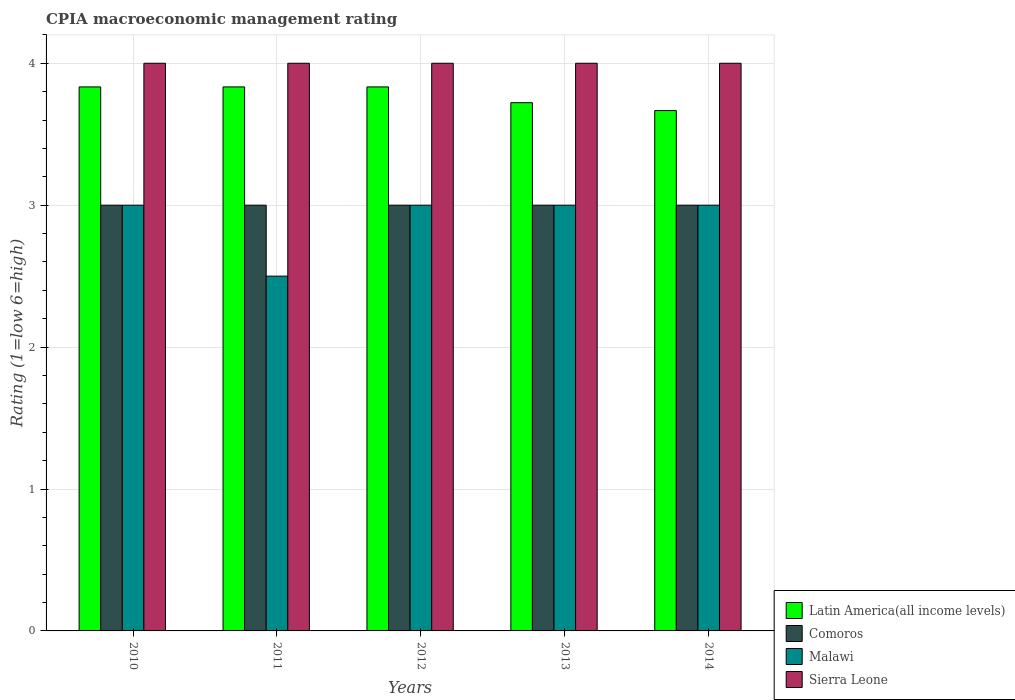How many different coloured bars are there?
Offer a very short reply. 4. How many groups of bars are there?
Provide a succinct answer. 5. Are the number of bars per tick equal to the number of legend labels?
Give a very brief answer. Yes. How many bars are there on the 5th tick from the right?
Ensure brevity in your answer.  4. In how many cases, is the number of bars for a given year not equal to the number of legend labels?
Your answer should be compact. 0. What is the CPIA rating in Sierra Leone in 2010?
Your response must be concise. 4. Across all years, what is the maximum CPIA rating in Sierra Leone?
Your answer should be very brief. 4. Across all years, what is the minimum CPIA rating in Sierra Leone?
Offer a very short reply. 4. In which year was the CPIA rating in Sierra Leone maximum?
Your answer should be very brief. 2010. In which year was the CPIA rating in Comoros minimum?
Your response must be concise. 2010. What is the total CPIA rating in Comoros in the graph?
Provide a short and direct response. 15. What is the difference between the CPIA rating in Latin America(all income levels) in 2013 and that in 2014?
Provide a succinct answer. 0.06. In the year 2014, what is the difference between the CPIA rating in Latin America(all income levels) and CPIA rating in Sierra Leone?
Provide a short and direct response. -0.33. What is the ratio of the CPIA rating in Sierra Leone in 2010 to that in 2014?
Make the answer very short. 1. Is the difference between the CPIA rating in Latin America(all income levels) in 2010 and 2011 greater than the difference between the CPIA rating in Sierra Leone in 2010 and 2011?
Keep it short and to the point. No. What is the difference between the highest and the second highest CPIA rating in Malawi?
Ensure brevity in your answer.  0. What does the 2nd bar from the left in 2010 represents?
Your answer should be very brief. Comoros. What does the 4th bar from the right in 2014 represents?
Offer a terse response. Latin America(all income levels). How many bars are there?
Your response must be concise. 20. Does the graph contain any zero values?
Ensure brevity in your answer.  No. Does the graph contain grids?
Ensure brevity in your answer.  Yes. How are the legend labels stacked?
Your response must be concise. Vertical. What is the title of the graph?
Offer a terse response. CPIA macroeconomic management rating. What is the label or title of the X-axis?
Your answer should be very brief. Years. What is the Rating (1=low 6=high) in Latin America(all income levels) in 2010?
Provide a succinct answer. 3.83. What is the Rating (1=low 6=high) of Malawi in 2010?
Offer a terse response. 3. What is the Rating (1=low 6=high) in Latin America(all income levels) in 2011?
Your answer should be very brief. 3.83. What is the Rating (1=low 6=high) of Sierra Leone in 2011?
Your answer should be very brief. 4. What is the Rating (1=low 6=high) of Latin America(all income levels) in 2012?
Provide a short and direct response. 3.83. What is the Rating (1=low 6=high) of Malawi in 2012?
Provide a succinct answer. 3. What is the Rating (1=low 6=high) in Sierra Leone in 2012?
Ensure brevity in your answer.  4. What is the Rating (1=low 6=high) of Latin America(all income levels) in 2013?
Your response must be concise. 3.72. What is the Rating (1=low 6=high) in Comoros in 2013?
Keep it short and to the point. 3. What is the Rating (1=low 6=high) in Sierra Leone in 2013?
Your response must be concise. 4. What is the Rating (1=low 6=high) of Latin America(all income levels) in 2014?
Your answer should be very brief. 3.67. What is the Rating (1=low 6=high) in Malawi in 2014?
Make the answer very short. 3. What is the Rating (1=low 6=high) in Sierra Leone in 2014?
Make the answer very short. 4. Across all years, what is the maximum Rating (1=low 6=high) in Latin America(all income levels)?
Offer a terse response. 3.83. Across all years, what is the maximum Rating (1=low 6=high) in Comoros?
Provide a succinct answer. 3. Across all years, what is the maximum Rating (1=low 6=high) in Malawi?
Provide a short and direct response. 3. Across all years, what is the minimum Rating (1=low 6=high) in Latin America(all income levels)?
Your answer should be very brief. 3.67. Across all years, what is the minimum Rating (1=low 6=high) in Comoros?
Your answer should be very brief. 3. Across all years, what is the minimum Rating (1=low 6=high) in Malawi?
Offer a terse response. 2.5. Across all years, what is the minimum Rating (1=low 6=high) of Sierra Leone?
Offer a terse response. 4. What is the total Rating (1=low 6=high) of Latin America(all income levels) in the graph?
Your response must be concise. 18.89. What is the total Rating (1=low 6=high) in Comoros in the graph?
Offer a terse response. 15. What is the total Rating (1=low 6=high) of Malawi in the graph?
Make the answer very short. 14.5. What is the difference between the Rating (1=low 6=high) of Latin America(all income levels) in 2010 and that in 2011?
Offer a very short reply. 0. What is the difference between the Rating (1=low 6=high) of Sierra Leone in 2010 and that in 2011?
Provide a succinct answer. 0. What is the difference between the Rating (1=low 6=high) of Latin America(all income levels) in 2010 and that in 2012?
Ensure brevity in your answer.  0. What is the difference between the Rating (1=low 6=high) in Comoros in 2010 and that in 2012?
Offer a very short reply. 0. What is the difference between the Rating (1=low 6=high) of Malawi in 2010 and that in 2012?
Provide a short and direct response. 0. What is the difference between the Rating (1=low 6=high) in Sierra Leone in 2010 and that in 2012?
Your response must be concise. 0. What is the difference between the Rating (1=low 6=high) of Latin America(all income levels) in 2010 and that in 2013?
Keep it short and to the point. 0.11. What is the difference between the Rating (1=low 6=high) of Comoros in 2010 and that in 2013?
Make the answer very short. 0. What is the difference between the Rating (1=low 6=high) in Sierra Leone in 2010 and that in 2013?
Make the answer very short. 0. What is the difference between the Rating (1=low 6=high) in Latin America(all income levels) in 2010 and that in 2014?
Give a very brief answer. 0.17. What is the difference between the Rating (1=low 6=high) in Comoros in 2010 and that in 2014?
Your answer should be very brief. 0. What is the difference between the Rating (1=low 6=high) of Comoros in 2011 and that in 2012?
Your answer should be very brief. 0. What is the difference between the Rating (1=low 6=high) of Malawi in 2011 and that in 2012?
Provide a succinct answer. -0.5. What is the difference between the Rating (1=low 6=high) in Comoros in 2011 and that in 2013?
Give a very brief answer. 0. What is the difference between the Rating (1=low 6=high) in Malawi in 2011 and that in 2013?
Your answer should be very brief. -0.5. What is the difference between the Rating (1=low 6=high) of Latin America(all income levels) in 2011 and that in 2014?
Provide a short and direct response. 0.17. What is the difference between the Rating (1=low 6=high) of Malawi in 2011 and that in 2014?
Offer a terse response. -0.5. What is the difference between the Rating (1=low 6=high) of Latin America(all income levels) in 2012 and that in 2013?
Provide a short and direct response. 0.11. What is the difference between the Rating (1=low 6=high) of Comoros in 2012 and that in 2013?
Offer a terse response. 0. What is the difference between the Rating (1=low 6=high) of Sierra Leone in 2012 and that in 2013?
Give a very brief answer. 0. What is the difference between the Rating (1=low 6=high) in Latin America(all income levels) in 2012 and that in 2014?
Make the answer very short. 0.17. What is the difference between the Rating (1=low 6=high) of Comoros in 2012 and that in 2014?
Offer a terse response. 0. What is the difference between the Rating (1=low 6=high) in Sierra Leone in 2012 and that in 2014?
Ensure brevity in your answer.  0. What is the difference between the Rating (1=low 6=high) of Latin America(all income levels) in 2013 and that in 2014?
Provide a short and direct response. 0.06. What is the difference between the Rating (1=low 6=high) of Comoros in 2013 and that in 2014?
Ensure brevity in your answer.  0. What is the difference between the Rating (1=low 6=high) in Malawi in 2013 and that in 2014?
Your response must be concise. 0. What is the difference between the Rating (1=low 6=high) of Latin America(all income levels) in 2010 and the Rating (1=low 6=high) of Comoros in 2011?
Your response must be concise. 0.83. What is the difference between the Rating (1=low 6=high) in Comoros in 2010 and the Rating (1=low 6=high) in Malawi in 2011?
Give a very brief answer. 0.5. What is the difference between the Rating (1=low 6=high) in Latin America(all income levels) in 2010 and the Rating (1=low 6=high) in Comoros in 2012?
Your answer should be compact. 0.83. What is the difference between the Rating (1=low 6=high) of Latin America(all income levels) in 2010 and the Rating (1=low 6=high) of Sierra Leone in 2012?
Provide a succinct answer. -0.17. What is the difference between the Rating (1=low 6=high) of Comoros in 2010 and the Rating (1=low 6=high) of Malawi in 2012?
Make the answer very short. 0. What is the difference between the Rating (1=low 6=high) of Comoros in 2010 and the Rating (1=low 6=high) of Sierra Leone in 2012?
Ensure brevity in your answer.  -1. What is the difference between the Rating (1=low 6=high) in Malawi in 2010 and the Rating (1=low 6=high) in Sierra Leone in 2012?
Keep it short and to the point. -1. What is the difference between the Rating (1=low 6=high) of Latin America(all income levels) in 2010 and the Rating (1=low 6=high) of Comoros in 2013?
Your response must be concise. 0.83. What is the difference between the Rating (1=low 6=high) of Latin America(all income levels) in 2010 and the Rating (1=low 6=high) of Sierra Leone in 2013?
Keep it short and to the point. -0.17. What is the difference between the Rating (1=low 6=high) in Comoros in 2010 and the Rating (1=low 6=high) in Malawi in 2013?
Your answer should be compact. 0. What is the difference between the Rating (1=low 6=high) in Comoros in 2010 and the Rating (1=low 6=high) in Sierra Leone in 2013?
Provide a succinct answer. -1. What is the difference between the Rating (1=low 6=high) of Latin America(all income levels) in 2010 and the Rating (1=low 6=high) of Comoros in 2014?
Provide a succinct answer. 0.83. What is the difference between the Rating (1=low 6=high) of Latin America(all income levels) in 2010 and the Rating (1=low 6=high) of Malawi in 2014?
Ensure brevity in your answer.  0.83. What is the difference between the Rating (1=low 6=high) in Comoros in 2010 and the Rating (1=low 6=high) in Sierra Leone in 2014?
Your answer should be very brief. -1. What is the difference between the Rating (1=low 6=high) in Latin America(all income levels) in 2011 and the Rating (1=low 6=high) in Malawi in 2012?
Keep it short and to the point. 0.83. What is the difference between the Rating (1=low 6=high) of Comoros in 2011 and the Rating (1=low 6=high) of Malawi in 2012?
Offer a very short reply. 0. What is the difference between the Rating (1=low 6=high) in Latin America(all income levels) in 2011 and the Rating (1=low 6=high) in Comoros in 2013?
Your response must be concise. 0.83. What is the difference between the Rating (1=low 6=high) of Latin America(all income levels) in 2011 and the Rating (1=low 6=high) of Malawi in 2013?
Ensure brevity in your answer.  0.83. What is the difference between the Rating (1=low 6=high) in Latin America(all income levels) in 2011 and the Rating (1=low 6=high) in Sierra Leone in 2013?
Keep it short and to the point. -0.17. What is the difference between the Rating (1=low 6=high) of Comoros in 2011 and the Rating (1=low 6=high) of Malawi in 2013?
Keep it short and to the point. 0. What is the difference between the Rating (1=low 6=high) of Latin America(all income levels) in 2011 and the Rating (1=low 6=high) of Comoros in 2014?
Give a very brief answer. 0.83. What is the difference between the Rating (1=low 6=high) of Comoros in 2011 and the Rating (1=low 6=high) of Malawi in 2014?
Make the answer very short. 0. What is the difference between the Rating (1=low 6=high) of Comoros in 2011 and the Rating (1=low 6=high) of Sierra Leone in 2014?
Your response must be concise. -1. What is the difference between the Rating (1=low 6=high) of Latin America(all income levels) in 2012 and the Rating (1=low 6=high) of Comoros in 2013?
Provide a succinct answer. 0.83. What is the difference between the Rating (1=low 6=high) of Comoros in 2012 and the Rating (1=low 6=high) of Sierra Leone in 2013?
Give a very brief answer. -1. What is the difference between the Rating (1=low 6=high) of Malawi in 2012 and the Rating (1=low 6=high) of Sierra Leone in 2013?
Your response must be concise. -1. What is the difference between the Rating (1=low 6=high) of Latin America(all income levels) in 2012 and the Rating (1=low 6=high) of Comoros in 2014?
Your response must be concise. 0.83. What is the difference between the Rating (1=low 6=high) in Latin America(all income levels) in 2012 and the Rating (1=low 6=high) in Sierra Leone in 2014?
Your response must be concise. -0.17. What is the difference between the Rating (1=low 6=high) in Comoros in 2012 and the Rating (1=low 6=high) in Sierra Leone in 2014?
Give a very brief answer. -1. What is the difference between the Rating (1=low 6=high) in Latin America(all income levels) in 2013 and the Rating (1=low 6=high) in Comoros in 2014?
Provide a succinct answer. 0.72. What is the difference between the Rating (1=low 6=high) in Latin America(all income levels) in 2013 and the Rating (1=low 6=high) in Malawi in 2014?
Offer a terse response. 0.72. What is the difference between the Rating (1=low 6=high) of Latin America(all income levels) in 2013 and the Rating (1=low 6=high) of Sierra Leone in 2014?
Make the answer very short. -0.28. What is the difference between the Rating (1=low 6=high) of Comoros in 2013 and the Rating (1=low 6=high) of Malawi in 2014?
Offer a very short reply. 0. What is the average Rating (1=low 6=high) in Latin America(all income levels) per year?
Your answer should be very brief. 3.78. In the year 2010, what is the difference between the Rating (1=low 6=high) in Latin America(all income levels) and Rating (1=low 6=high) in Malawi?
Provide a short and direct response. 0.83. In the year 2010, what is the difference between the Rating (1=low 6=high) in Latin America(all income levels) and Rating (1=low 6=high) in Sierra Leone?
Offer a very short reply. -0.17. In the year 2010, what is the difference between the Rating (1=low 6=high) of Comoros and Rating (1=low 6=high) of Sierra Leone?
Make the answer very short. -1. In the year 2011, what is the difference between the Rating (1=low 6=high) in Latin America(all income levels) and Rating (1=low 6=high) in Comoros?
Ensure brevity in your answer.  0.83. In the year 2011, what is the difference between the Rating (1=low 6=high) in Latin America(all income levels) and Rating (1=low 6=high) in Malawi?
Provide a succinct answer. 1.33. In the year 2011, what is the difference between the Rating (1=low 6=high) of Latin America(all income levels) and Rating (1=low 6=high) of Sierra Leone?
Keep it short and to the point. -0.17. In the year 2011, what is the difference between the Rating (1=low 6=high) of Comoros and Rating (1=low 6=high) of Malawi?
Keep it short and to the point. 0.5. In the year 2011, what is the difference between the Rating (1=low 6=high) of Malawi and Rating (1=low 6=high) of Sierra Leone?
Offer a very short reply. -1.5. In the year 2012, what is the difference between the Rating (1=low 6=high) of Latin America(all income levels) and Rating (1=low 6=high) of Comoros?
Provide a short and direct response. 0.83. In the year 2012, what is the difference between the Rating (1=low 6=high) of Latin America(all income levels) and Rating (1=low 6=high) of Malawi?
Your answer should be very brief. 0.83. In the year 2012, what is the difference between the Rating (1=low 6=high) of Latin America(all income levels) and Rating (1=low 6=high) of Sierra Leone?
Your response must be concise. -0.17. In the year 2012, what is the difference between the Rating (1=low 6=high) in Malawi and Rating (1=low 6=high) in Sierra Leone?
Your answer should be compact. -1. In the year 2013, what is the difference between the Rating (1=low 6=high) in Latin America(all income levels) and Rating (1=low 6=high) in Comoros?
Provide a short and direct response. 0.72. In the year 2013, what is the difference between the Rating (1=low 6=high) of Latin America(all income levels) and Rating (1=low 6=high) of Malawi?
Offer a very short reply. 0.72. In the year 2013, what is the difference between the Rating (1=low 6=high) of Latin America(all income levels) and Rating (1=low 6=high) of Sierra Leone?
Your response must be concise. -0.28. In the year 2013, what is the difference between the Rating (1=low 6=high) of Comoros and Rating (1=low 6=high) of Sierra Leone?
Give a very brief answer. -1. In the year 2014, what is the difference between the Rating (1=low 6=high) of Latin America(all income levels) and Rating (1=low 6=high) of Sierra Leone?
Ensure brevity in your answer.  -0.33. What is the ratio of the Rating (1=low 6=high) of Latin America(all income levels) in 2010 to that in 2011?
Make the answer very short. 1. What is the ratio of the Rating (1=low 6=high) in Malawi in 2010 to that in 2011?
Give a very brief answer. 1.2. What is the ratio of the Rating (1=low 6=high) in Sierra Leone in 2010 to that in 2011?
Provide a succinct answer. 1. What is the ratio of the Rating (1=low 6=high) of Latin America(all income levels) in 2010 to that in 2012?
Offer a very short reply. 1. What is the ratio of the Rating (1=low 6=high) of Comoros in 2010 to that in 2012?
Ensure brevity in your answer.  1. What is the ratio of the Rating (1=low 6=high) of Sierra Leone in 2010 to that in 2012?
Your response must be concise. 1. What is the ratio of the Rating (1=low 6=high) of Latin America(all income levels) in 2010 to that in 2013?
Ensure brevity in your answer.  1.03. What is the ratio of the Rating (1=low 6=high) in Comoros in 2010 to that in 2013?
Your answer should be compact. 1. What is the ratio of the Rating (1=low 6=high) of Sierra Leone in 2010 to that in 2013?
Ensure brevity in your answer.  1. What is the ratio of the Rating (1=low 6=high) of Latin America(all income levels) in 2010 to that in 2014?
Offer a very short reply. 1.05. What is the ratio of the Rating (1=low 6=high) in Malawi in 2010 to that in 2014?
Ensure brevity in your answer.  1. What is the ratio of the Rating (1=low 6=high) in Latin America(all income levels) in 2011 to that in 2012?
Offer a very short reply. 1. What is the ratio of the Rating (1=low 6=high) of Comoros in 2011 to that in 2012?
Give a very brief answer. 1. What is the ratio of the Rating (1=low 6=high) in Latin America(all income levels) in 2011 to that in 2013?
Ensure brevity in your answer.  1.03. What is the ratio of the Rating (1=low 6=high) of Comoros in 2011 to that in 2013?
Make the answer very short. 1. What is the ratio of the Rating (1=low 6=high) of Latin America(all income levels) in 2011 to that in 2014?
Keep it short and to the point. 1.05. What is the ratio of the Rating (1=low 6=high) of Sierra Leone in 2011 to that in 2014?
Your answer should be compact. 1. What is the ratio of the Rating (1=low 6=high) of Latin America(all income levels) in 2012 to that in 2013?
Your answer should be very brief. 1.03. What is the ratio of the Rating (1=low 6=high) in Latin America(all income levels) in 2012 to that in 2014?
Ensure brevity in your answer.  1.05. What is the ratio of the Rating (1=low 6=high) of Comoros in 2012 to that in 2014?
Your answer should be very brief. 1. What is the ratio of the Rating (1=low 6=high) in Malawi in 2012 to that in 2014?
Your answer should be compact. 1. What is the ratio of the Rating (1=low 6=high) in Latin America(all income levels) in 2013 to that in 2014?
Provide a short and direct response. 1.02. What is the ratio of the Rating (1=low 6=high) of Comoros in 2013 to that in 2014?
Offer a terse response. 1. What is the ratio of the Rating (1=low 6=high) of Malawi in 2013 to that in 2014?
Offer a terse response. 1. What is the difference between the highest and the second highest Rating (1=low 6=high) in Latin America(all income levels)?
Make the answer very short. 0. What is the difference between the highest and the second highest Rating (1=low 6=high) of Comoros?
Provide a succinct answer. 0. What is the difference between the highest and the lowest Rating (1=low 6=high) of Sierra Leone?
Your answer should be very brief. 0. 